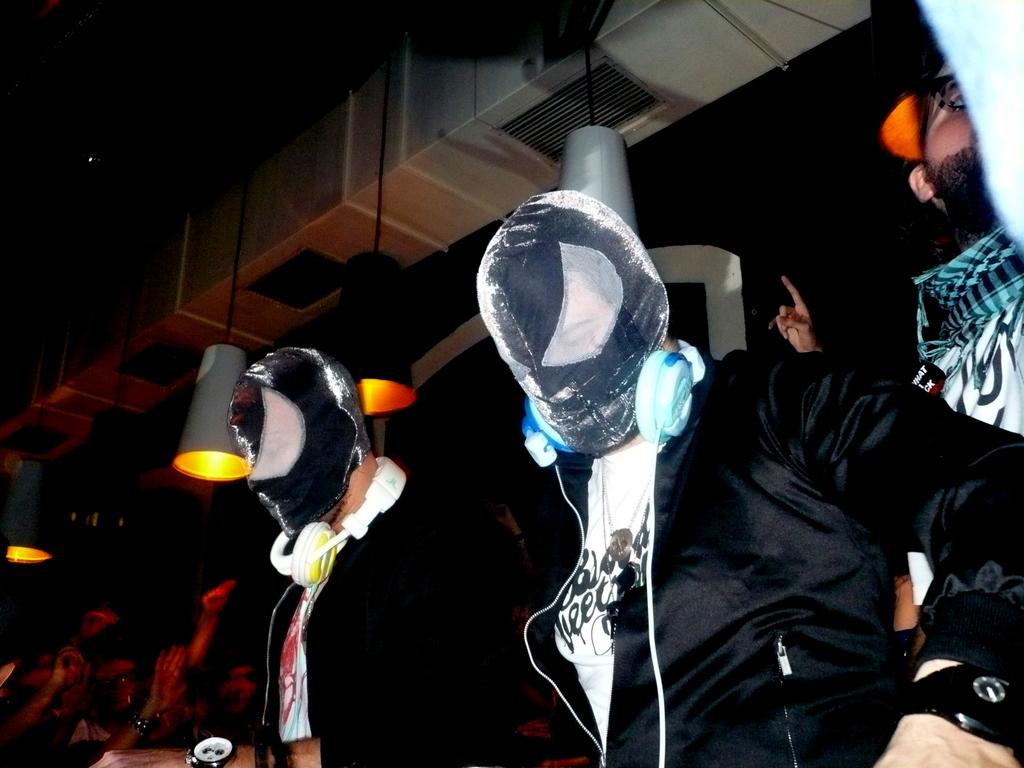What can be seen in the image? There is a group of people in the image. How are the people dressed? The people are wearing different color dresses. Are there any accessories or protective gear visible? Some people in the group are wearing masks. What can be seen in the foreground of the image? There are lights visible in the image. What is the condition of the background in the image? The background of the image is blurred. What type of bells can be heard ringing in the image? There are no bells present in the image, and therefore no sound can be heard. What type of jeans are the people wearing in the image? The provided facts do not mention any jeans being worn by the people in the image. 